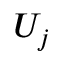<formula> <loc_0><loc_0><loc_500><loc_500>U _ { j }</formula> 